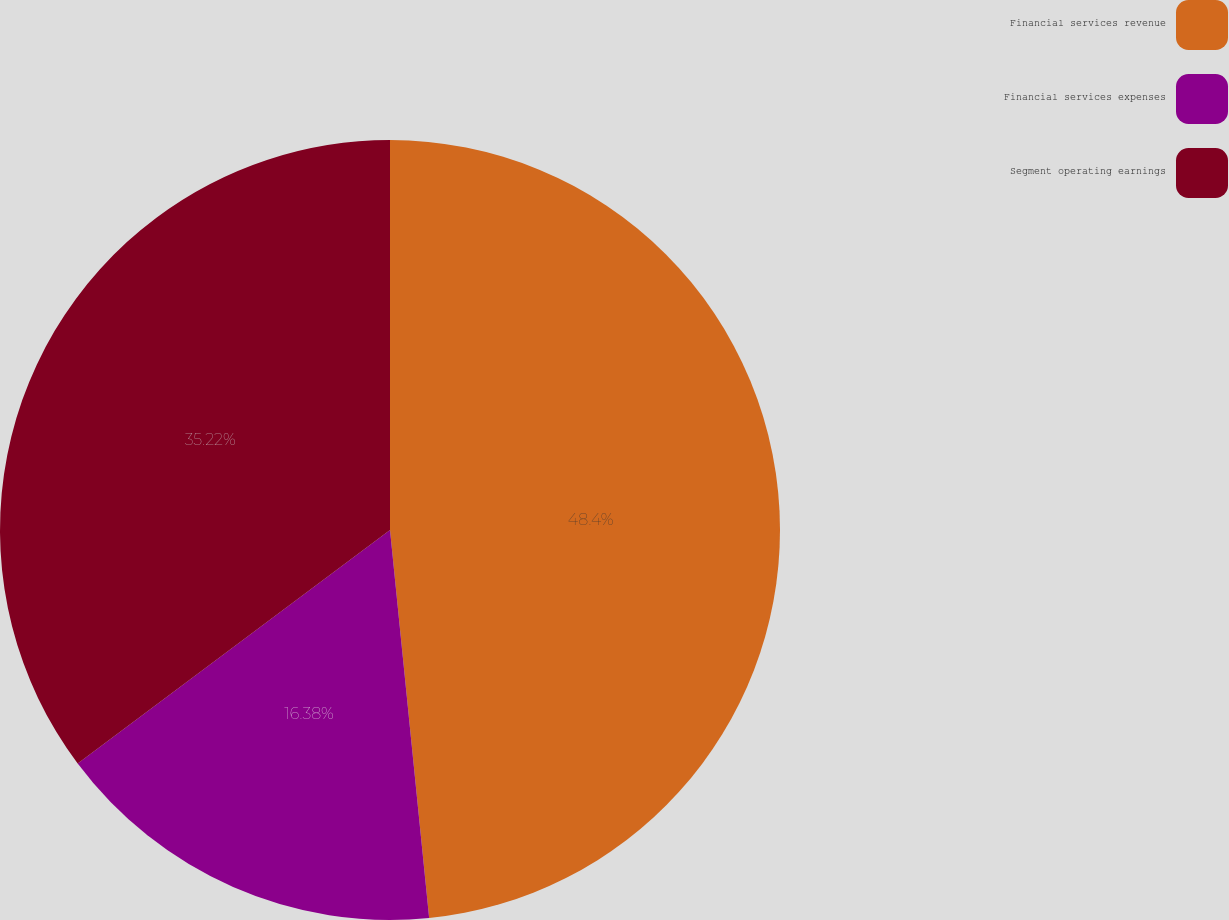Convert chart to OTSL. <chart><loc_0><loc_0><loc_500><loc_500><pie_chart><fcel>Financial services revenue<fcel>Financial services expenses<fcel>Segment operating earnings<nl><fcel>48.4%<fcel>16.38%<fcel>35.22%<nl></chart> 